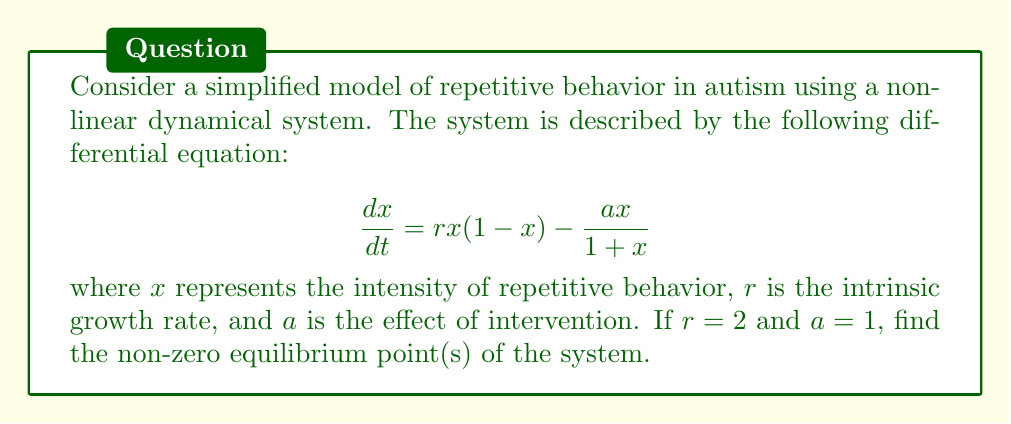What is the answer to this math problem? To find the equilibrium points, we set the derivative to zero:

$$\frac{dx}{dt} = 0$$

Substituting the given equation:

$$rx(1-x) - \frac{ax}{1+x} = 0$$

Plugging in the values $r = 2$ and $a = 1$:

$$2x(1-x) - \frac{x}{1+x} = 0$$

Multiply both sides by $(1+x)$:

$$2x(1-x)(1+x) - x = 0$$

Expand the equation:

$$2x(1-x^2) - x = 0$$
$$2x - 2x^3 - x = 0$$
$$x(2 - 2x^2 - 1) = 0$$
$$x(1 - 2x^2) = 0$$

The solutions to this equation are the equilibrium points. We can factor out $x$:

$$x = 0$$ or $$1 - 2x^2 = 0$$

Solving the second equation:

$$2x^2 = 1$$
$$x^2 = \frac{1}{2}$$
$$x = \pm \frac{1}{\sqrt{2}}$$

The non-zero equilibrium points are $x = \frac{1}{\sqrt{2}}$ and $x = -\frac{1}{\sqrt{2}}$. However, since $x$ represents intensity of behavior, which cannot be negative, we only consider the positive solution.
Answer: $\frac{1}{\sqrt{2}}$ 